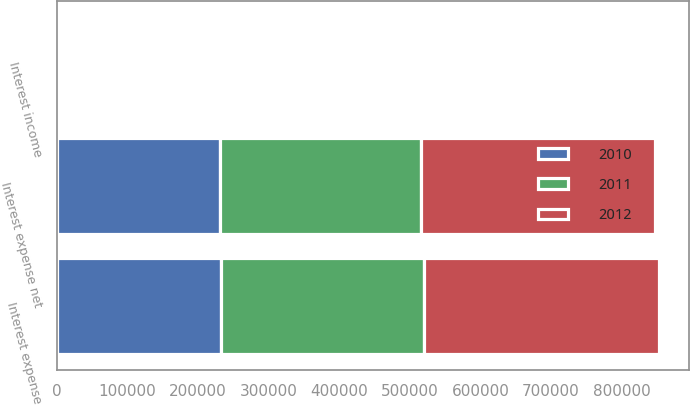<chart> <loc_0><loc_0><loc_500><loc_500><stacked_bar_chart><ecel><fcel>Interest expense<fcel>Interest income<fcel>Interest expense net<nl><fcel>2012<fcel>332188<fcel>1619<fcel>330569<nl><fcel>2011<fcel>287921<fcel>2004<fcel>285917<nl><fcel>2010<fcel>232794<fcel>2146<fcel>230648<nl></chart> 